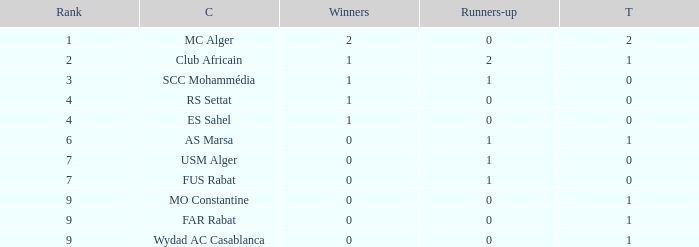Which Winners is the highest one that has a Rank larger than 7, and a Third smaller than 1? None. 